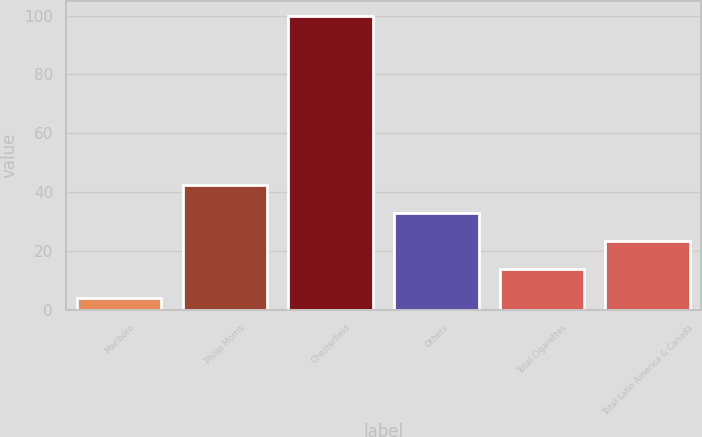Convert chart to OTSL. <chart><loc_0><loc_0><loc_500><loc_500><bar_chart><fcel>Marlboro<fcel>Philip Morris<fcel>Chesterfield<fcel>Others<fcel>Total Cigarettes<fcel>Total Latin America & Canada<nl><fcel>4.2<fcel>42.52<fcel>100<fcel>32.94<fcel>13.78<fcel>23.36<nl></chart> 